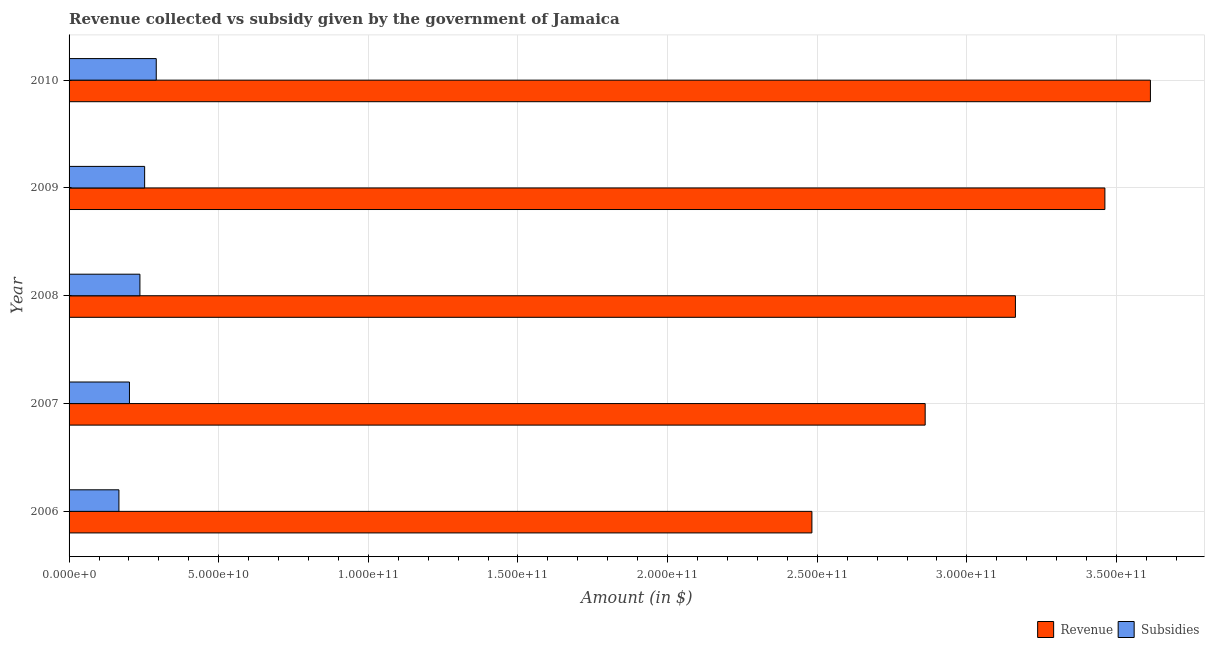Are the number of bars per tick equal to the number of legend labels?
Provide a succinct answer. Yes. Are the number of bars on each tick of the Y-axis equal?
Your answer should be very brief. Yes. How many bars are there on the 4th tick from the top?
Make the answer very short. 2. How many bars are there on the 3rd tick from the bottom?
Ensure brevity in your answer.  2. In how many cases, is the number of bars for a given year not equal to the number of legend labels?
Your response must be concise. 0. What is the amount of subsidies given in 2010?
Offer a terse response. 2.91e+1. Across all years, what is the maximum amount of subsidies given?
Offer a terse response. 2.91e+1. Across all years, what is the minimum amount of revenue collected?
Your answer should be compact. 2.48e+11. What is the total amount of subsidies given in the graph?
Offer a terse response. 1.15e+11. What is the difference between the amount of revenue collected in 2006 and that in 2010?
Your response must be concise. -1.13e+11. What is the difference between the amount of revenue collected in 2007 and the amount of subsidies given in 2009?
Offer a very short reply. 2.61e+11. What is the average amount of subsidies given per year?
Give a very brief answer. 2.30e+1. In the year 2009, what is the difference between the amount of subsidies given and amount of revenue collected?
Your answer should be very brief. -3.21e+11. What is the ratio of the amount of revenue collected in 2008 to that in 2010?
Your answer should be very brief. 0.88. Is the amount of subsidies given in 2009 less than that in 2010?
Your response must be concise. Yes. What is the difference between the highest and the second highest amount of revenue collected?
Provide a succinct answer. 1.52e+1. What is the difference between the highest and the lowest amount of subsidies given?
Provide a short and direct response. 1.25e+1. Is the sum of the amount of subsidies given in 2007 and 2009 greater than the maximum amount of revenue collected across all years?
Provide a short and direct response. No. What does the 2nd bar from the top in 2010 represents?
Offer a terse response. Revenue. What does the 1st bar from the bottom in 2007 represents?
Provide a succinct answer. Revenue. Are all the bars in the graph horizontal?
Your response must be concise. Yes. How many years are there in the graph?
Offer a very short reply. 5. Are the values on the major ticks of X-axis written in scientific E-notation?
Make the answer very short. Yes. Does the graph contain any zero values?
Keep it short and to the point. No. Where does the legend appear in the graph?
Offer a terse response. Bottom right. How many legend labels are there?
Offer a very short reply. 2. What is the title of the graph?
Make the answer very short. Revenue collected vs subsidy given by the government of Jamaica. What is the label or title of the X-axis?
Provide a short and direct response. Amount (in $). What is the label or title of the Y-axis?
Keep it short and to the point. Year. What is the Amount (in $) in Revenue in 2006?
Give a very brief answer. 2.48e+11. What is the Amount (in $) in Subsidies in 2006?
Provide a short and direct response. 1.67e+1. What is the Amount (in $) of Revenue in 2007?
Offer a very short reply. 2.86e+11. What is the Amount (in $) of Subsidies in 2007?
Offer a terse response. 2.02e+1. What is the Amount (in $) in Revenue in 2008?
Give a very brief answer. 3.16e+11. What is the Amount (in $) of Subsidies in 2008?
Offer a very short reply. 2.37e+1. What is the Amount (in $) in Revenue in 2009?
Keep it short and to the point. 3.46e+11. What is the Amount (in $) of Subsidies in 2009?
Offer a very short reply. 2.53e+1. What is the Amount (in $) of Revenue in 2010?
Make the answer very short. 3.61e+11. What is the Amount (in $) of Subsidies in 2010?
Your answer should be very brief. 2.91e+1. Across all years, what is the maximum Amount (in $) of Revenue?
Give a very brief answer. 3.61e+11. Across all years, what is the maximum Amount (in $) of Subsidies?
Ensure brevity in your answer.  2.91e+1. Across all years, what is the minimum Amount (in $) in Revenue?
Ensure brevity in your answer.  2.48e+11. Across all years, what is the minimum Amount (in $) in Subsidies?
Ensure brevity in your answer.  1.67e+1. What is the total Amount (in $) in Revenue in the graph?
Provide a succinct answer. 1.56e+12. What is the total Amount (in $) of Subsidies in the graph?
Offer a terse response. 1.15e+11. What is the difference between the Amount (in $) in Revenue in 2006 and that in 2007?
Offer a very short reply. -3.78e+1. What is the difference between the Amount (in $) of Subsidies in 2006 and that in 2007?
Make the answer very short. -3.52e+09. What is the difference between the Amount (in $) in Revenue in 2006 and that in 2008?
Offer a very short reply. -6.80e+1. What is the difference between the Amount (in $) of Subsidies in 2006 and that in 2008?
Provide a succinct answer. -7.02e+09. What is the difference between the Amount (in $) in Revenue in 2006 and that in 2009?
Offer a terse response. -9.79e+1. What is the difference between the Amount (in $) in Subsidies in 2006 and that in 2009?
Offer a terse response. -8.60e+09. What is the difference between the Amount (in $) of Revenue in 2006 and that in 2010?
Offer a terse response. -1.13e+11. What is the difference between the Amount (in $) in Subsidies in 2006 and that in 2010?
Provide a succinct answer. -1.25e+1. What is the difference between the Amount (in $) of Revenue in 2007 and that in 2008?
Your answer should be compact. -3.02e+1. What is the difference between the Amount (in $) of Subsidies in 2007 and that in 2008?
Provide a short and direct response. -3.50e+09. What is the difference between the Amount (in $) of Revenue in 2007 and that in 2009?
Keep it short and to the point. -6.01e+1. What is the difference between the Amount (in $) of Subsidies in 2007 and that in 2009?
Provide a short and direct response. -5.08e+09. What is the difference between the Amount (in $) in Revenue in 2007 and that in 2010?
Make the answer very short. -7.53e+1. What is the difference between the Amount (in $) in Subsidies in 2007 and that in 2010?
Your answer should be compact. -8.95e+09. What is the difference between the Amount (in $) of Revenue in 2008 and that in 2009?
Your answer should be compact. -2.99e+1. What is the difference between the Amount (in $) in Subsidies in 2008 and that in 2009?
Your answer should be compact. -1.58e+09. What is the difference between the Amount (in $) in Revenue in 2008 and that in 2010?
Make the answer very short. -4.51e+1. What is the difference between the Amount (in $) of Subsidies in 2008 and that in 2010?
Make the answer very short. -5.46e+09. What is the difference between the Amount (in $) of Revenue in 2009 and that in 2010?
Make the answer very short. -1.52e+1. What is the difference between the Amount (in $) of Subsidies in 2009 and that in 2010?
Provide a short and direct response. -3.88e+09. What is the difference between the Amount (in $) of Revenue in 2006 and the Amount (in $) of Subsidies in 2007?
Ensure brevity in your answer.  2.28e+11. What is the difference between the Amount (in $) of Revenue in 2006 and the Amount (in $) of Subsidies in 2008?
Offer a very short reply. 2.25e+11. What is the difference between the Amount (in $) of Revenue in 2006 and the Amount (in $) of Subsidies in 2009?
Give a very brief answer. 2.23e+11. What is the difference between the Amount (in $) of Revenue in 2006 and the Amount (in $) of Subsidies in 2010?
Your response must be concise. 2.19e+11. What is the difference between the Amount (in $) in Revenue in 2007 and the Amount (in $) in Subsidies in 2008?
Your answer should be very brief. 2.62e+11. What is the difference between the Amount (in $) in Revenue in 2007 and the Amount (in $) in Subsidies in 2009?
Give a very brief answer. 2.61e+11. What is the difference between the Amount (in $) in Revenue in 2007 and the Amount (in $) in Subsidies in 2010?
Provide a short and direct response. 2.57e+11. What is the difference between the Amount (in $) of Revenue in 2008 and the Amount (in $) of Subsidies in 2009?
Provide a short and direct response. 2.91e+11. What is the difference between the Amount (in $) in Revenue in 2008 and the Amount (in $) in Subsidies in 2010?
Your response must be concise. 2.87e+11. What is the difference between the Amount (in $) of Revenue in 2009 and the Amount (in $) of Subsidies in 2010?
Your answer should be compact. 3.17e+11. What is the average Amount (in $) of Revenue per year?
Make the answer very short. 3.12e+11. What is the average Amount (in $) of Subsidies per year?
Offer a very short reply. 2.30e+1. In the year 2006, what is the difference between the Amount (in $) of Revenue and Amount (in $) of Subsidies?
Ensure brevity in your answer.  2.32e+11. In the year 2007, what is the difference between the Amount (in $) of Revenue and Amount (in $) of Subsidies?
Make the answer very short. 2.66e+11. In the year 2008, what is the difference between the Amount (in $) in Revenue and Amount (in $) in Subsidies?
Provide a short and direct response. 2.93e+11. In the year 2009, what is the difference between the Amount (in $) of Revenue and Amount (in $) of Subsidies?
Provide a short and direct response. 3.21e+11. In the year 2010, what is the difference between the Amount (in $) of Revenue and Amount (in $) of Subsidies?
Provide a succinct answer. 3.32e+11. What is the ratio of the Amount (in $) in Revenue in 2006 to that in 2007?
Make the answer very short. 0.87. What is the ratio of the Amount (in $) in Subsidies in 2006 to that in 2007?
Offer a terse response. 0.83. What is the ratio of the Amount (in $) in Revenue in 2006 to that in 2008?
Make the answer very short. 0.78. What is the ratio of the Amount (in $) of Subsidies in 2006 to that in 2008?
Your answer should be compact. 0.7. What is the ratio of the Amount (in $) in Revenue in 2006 to that in 2009?
Offer a very short reply. 0.72. What is the ratio of the Amount (in $) of Subsidies in 2006 to that in 2009?
Provide a succinct answer. 0.66. What is the ratio of the Amount (in $) of Revenue in 2006 to that in 2010?
Offer a very short reply. 0.69. What is the ratio of the Amount (in $) in Subsidies in 2006 to that in 2010?
Keep it short and to the point. 0.57. What is the ratio of the Amount (in $) in Revenue in 2007 to that in 2008?
Your response must be concise. 0.9. What is the ratio of the Amount (in $) of Subsidies in 2007 to that in 2008?
Offer a very short reply. 0.85. What is the ratio of the Amount (in $) of Revenue in 2007 to that in 2009?
Provide a short and direct response. 0.83. What is the ratio of the Amount (in $) in Subsidies in 2007 to that in 2009?
Make the answer very short. 0.8. What is the ratio of the Amount (in $) of Revenue in 2007 to that in 2010?
Keep it short and to the point. 0.79. What is the ratio of the Amount (in $) of Subsidies in 2007 to that in 2010?
Your answer should be very brief. 0.69. What is the ratio of the Amount (in $) in Revenue in 2008 to that in 2009?
Keep it short and to the point. 0.91. What is the ratio of the Amount (in $) of Revenue in 2008 to that in 2010?
Provide a succinct answer. 0.88. What is the ratio of the Amount (in $) of Subsidies in 2008 to that in 2010?
Ensure brevity in your answer.  0.81. What is the ratio of the Amount (in $) in Revenue in 2009 to that in 2010?
Your answer should be compact. 0.96. What is the ratio of the Amount (in $) in Subsidies in 2009 to that in 2010?
Your answer should be very brief. 0.87. What is the difference between the highest and the second highest Amount (in $) in Revenue?
Give a very brief answer. 1.52e+1. What is the difference between the highest and the second highest Amount (in $) of Subsidies?
Ensure brevity in your answer.  3.88e+09. What is the difference between the highest and the lowest Amount (in $) in Revenue?
Ensure brevity in your answer.  1.13e+11. What is the difference between the highest and the lowest Amount (in $) in Subsidies?
Provide a short and direct response. 1.25e+1. 